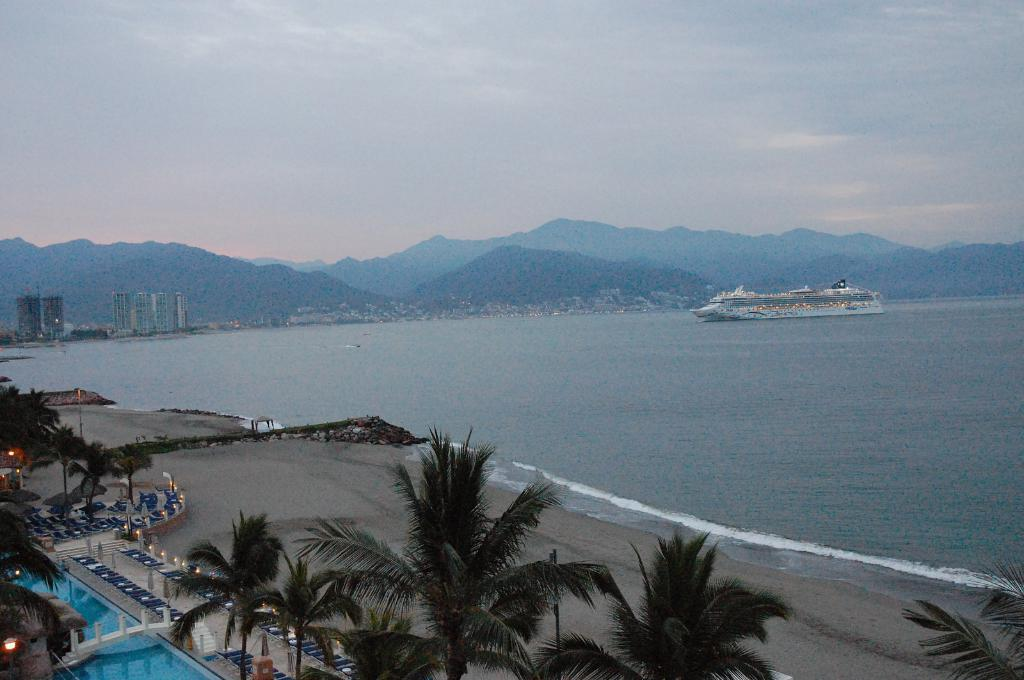What is the main subject of the image? There is a ship in the image. Where is the ship located? The ship is on water. What can be seen beside the water? There are trees beside the water. What other elements are visible in the image? There are lights, buildings, mountains, and the sky visible in the image. What type of whip is being used by the toad in the image? There is no toad or whip present in the image. 